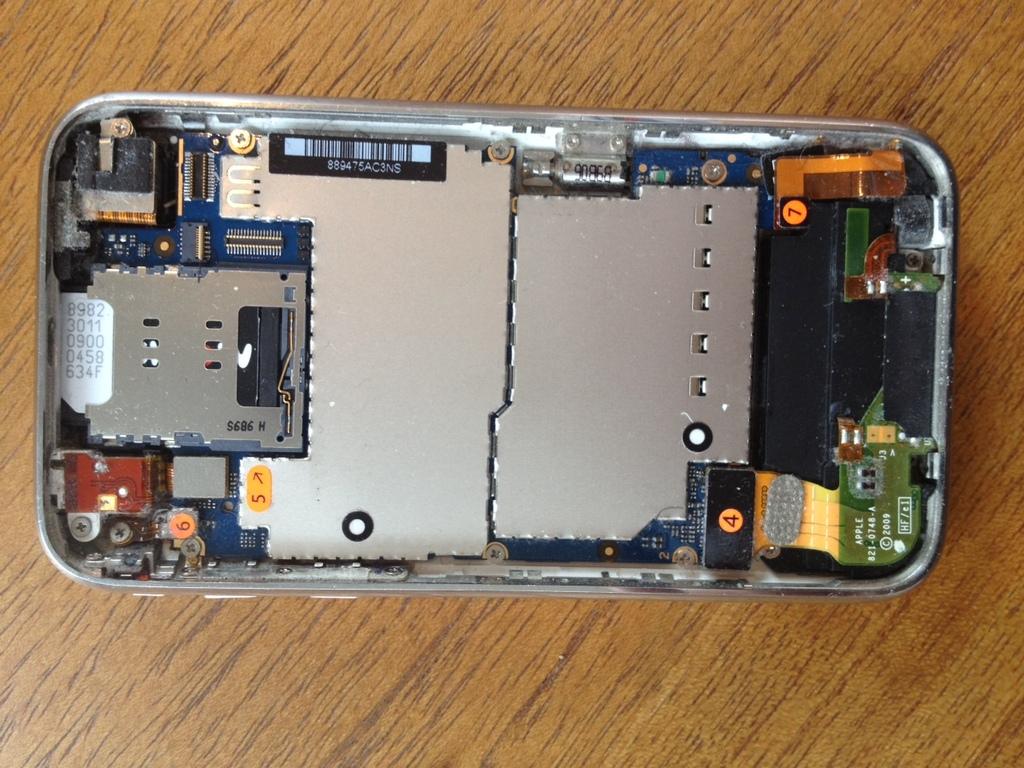What number is on the orange sticker on the small black rectangle component?
Your answer should be very brief. 4. 